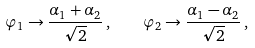<formula> <loc_0><loc_0><loc_500><loc_500>\varphi _ { 1 } \to \frac { \alpha _ { 1 } + \alpha _ { 2 } } { \sqrt { 2 } } \, , \quad \varphi _ { 2 } \to \frac { \alpha _ { 1 } - \alpha _ { 2 } } { \sqrt { 2 } } \, ,</formula> 